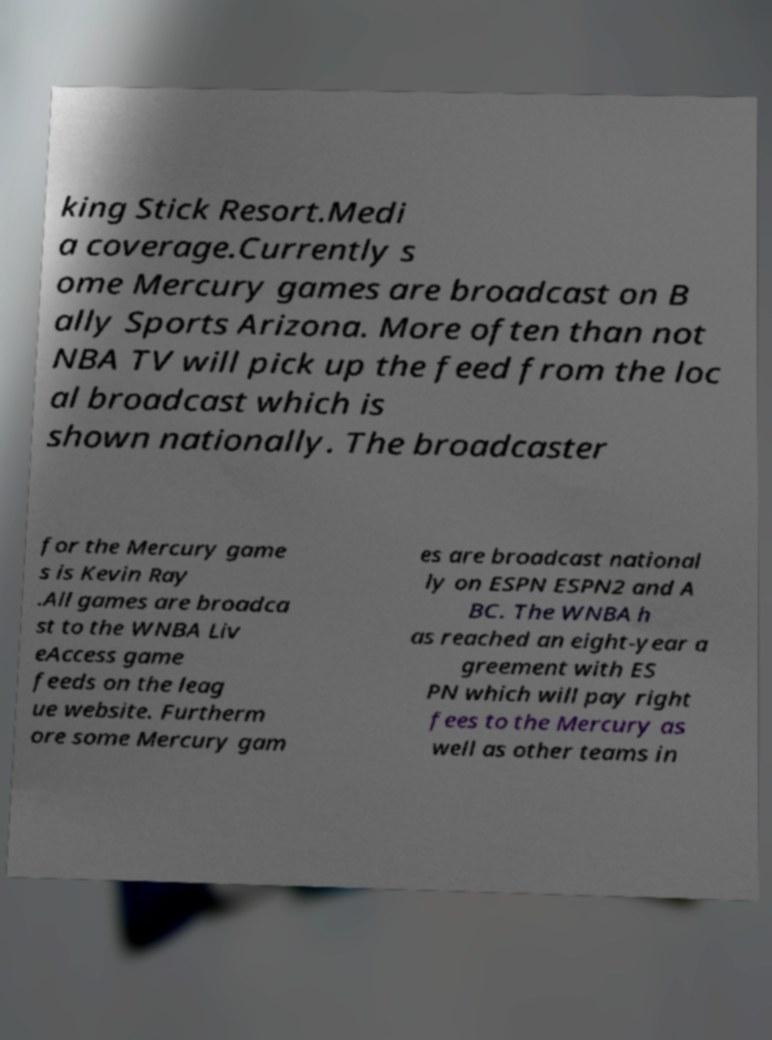I need the written content from this picture converted into text. Can you do that? king Stick Resort.Medi a coverage.Currently s ome Mercury games are broadcast on B ally Sports Arizona. More often than not NBA TV will pick up the feed from the loc al broadcast which is shown nationally. The broadcaster for the Mercury game s is Kevin Ray .All games are broadca st to the WNBA Liv eAccess game feeds on the leag ue website. Furtherm ore some Mercury gam es are broadcast national ly on ESPN ESPN2 and A BC. The WNBA h as reached an eight-year a greement with ES PN which will pay right fees to the Mercury as well as other teams in 